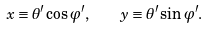<formula> <loc_0><loc_0><loc_500><loc_500>x \equiv \theta ^ { \prime } \cos \varphi ^ { \prime } , \quad y \equiv \theta ^ { \prime } \sin \varphi ^ { \prime } .</formula> 